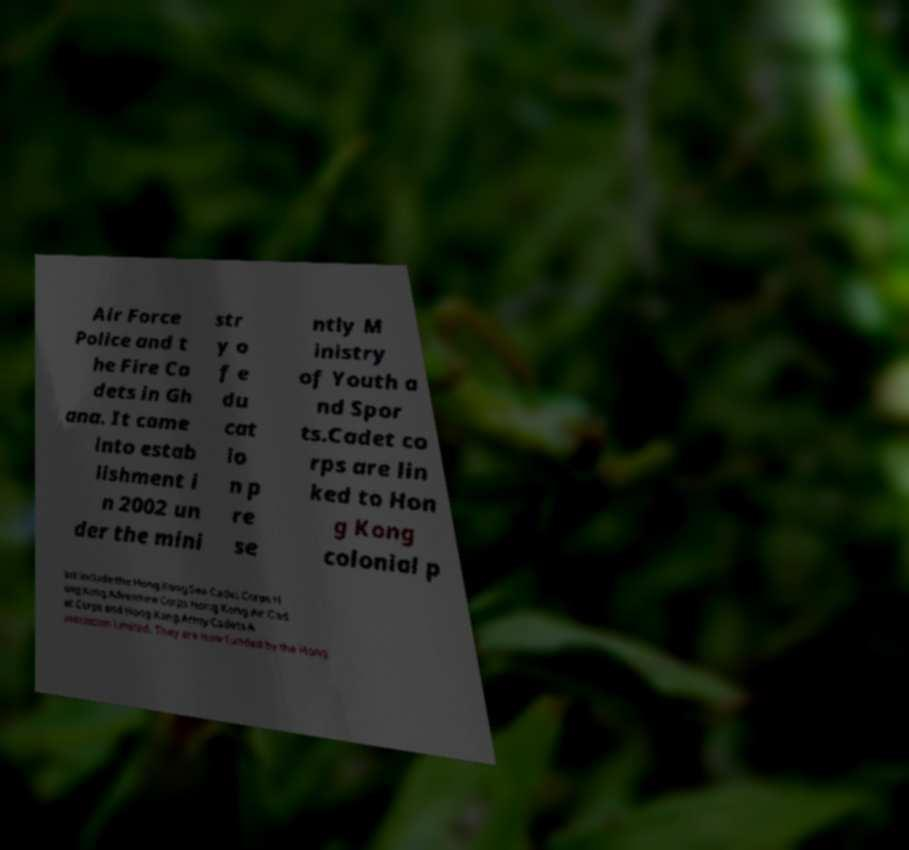There's text embedded in this image that I need extracted. Can you transcribe it verbatim? Air Force Police and t he Fire Ca dets in Gh ana. It came into estab lishment i n 2002 un der the mini str y o f e du cat io n p re se ntly M inistry of Youth a nd Spor ts.Cadet co rps are lin ked to Hon g Kong colonial p ast include the Hong Kong Sea Cadet Corps H ong Kong Adventure Corps Hong Kong Air Cad et Corps and Hong Kong Army Cadets A ssociation Limited. They are now funded by the Hong 